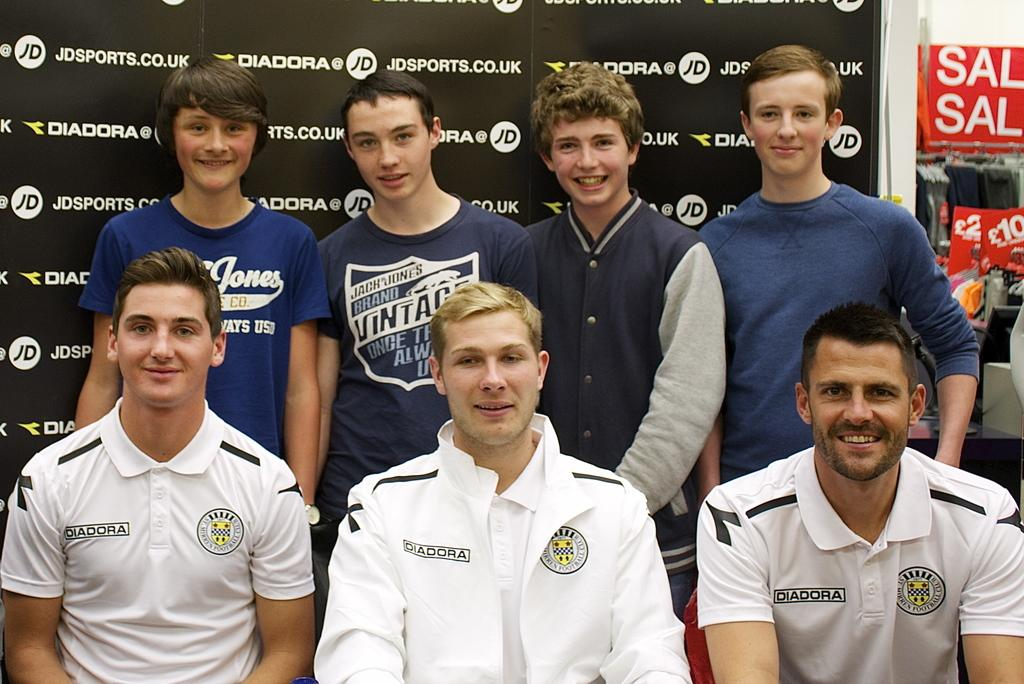<image>
Present a compact description of the photo's key features. Several men in front of a backdrop that says JDSPORTS.CO.UK. 